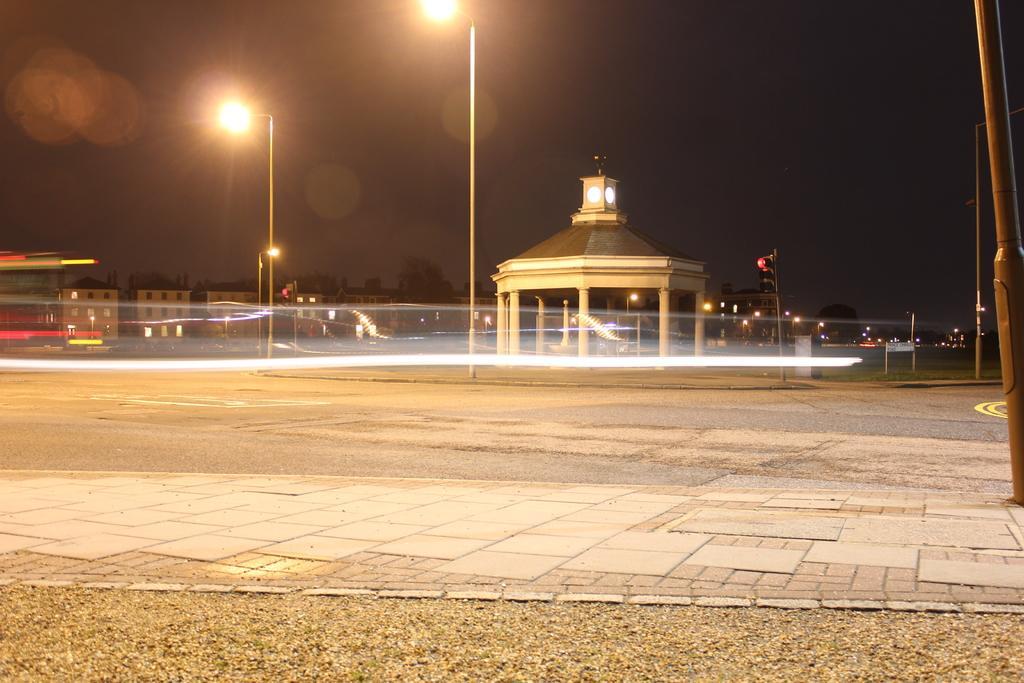Describe this image in one or two sentences. In the foreground of this image, there is path and the grass. On the right, there is a pole. In the background, there are buildings, trees, poles, a shelter, few lights and the dark sky. 